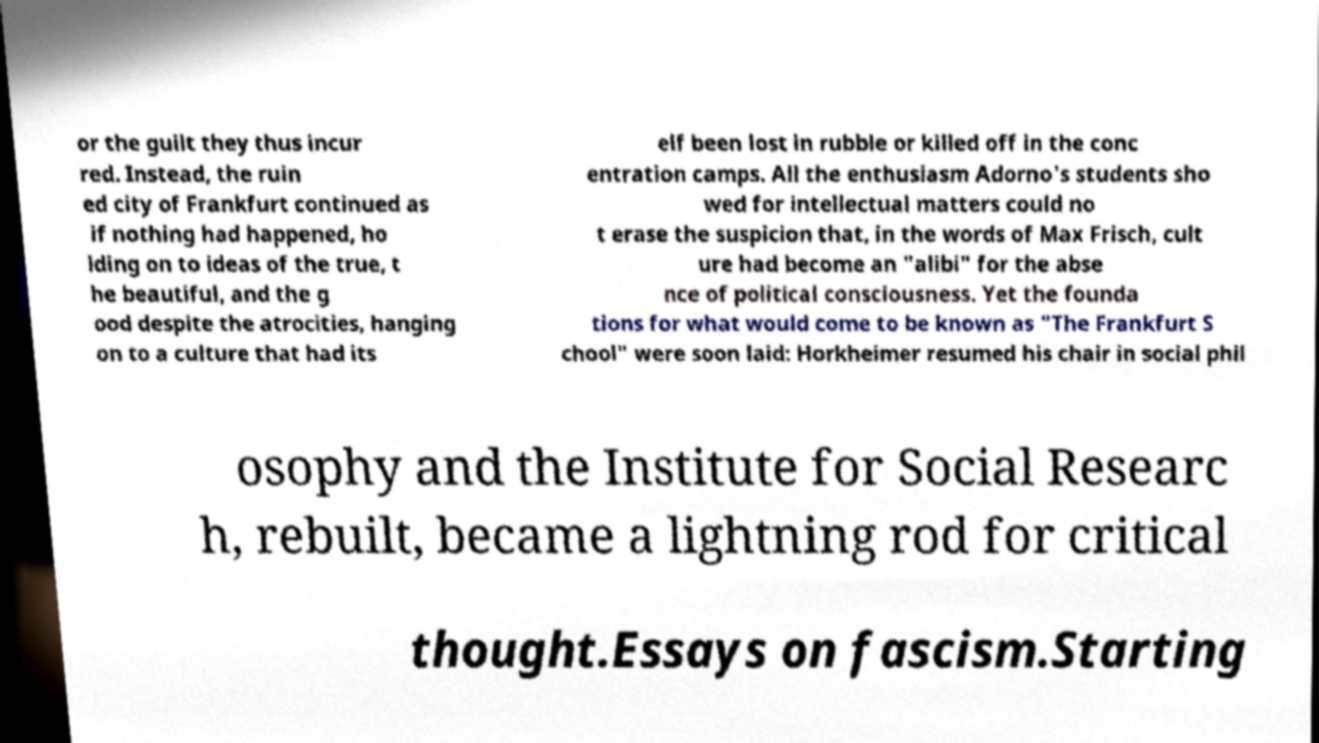What messages or text are displayed in this image? I need them in a readable, typed format. or the guilt they thus incur red. Instead, the ruin ed city of Frankfurt continued as if nothing had happened, ho lding on to ideas of the true, t he beautiful, and the g ood despite the atrocities, hanging on to a culture that had its elf been lost in rubble or killed off in the conc entration camps. All the enthusiasm Adorno's students sho wed for intellectual matters could no t erase the suspicion that, in the words of Max Frisch, cult ure had become an "alibi" for the abse nce of political consciousness. Yet the founda tions for what would come to be known as "The Frankfurt S chool" were soon laid: Horkheimer resumed his chair in social phil osophy and the Institute for Social Researc h, rebuilt, became a lightning rod for critical thought.Essays on fascism.Starting 